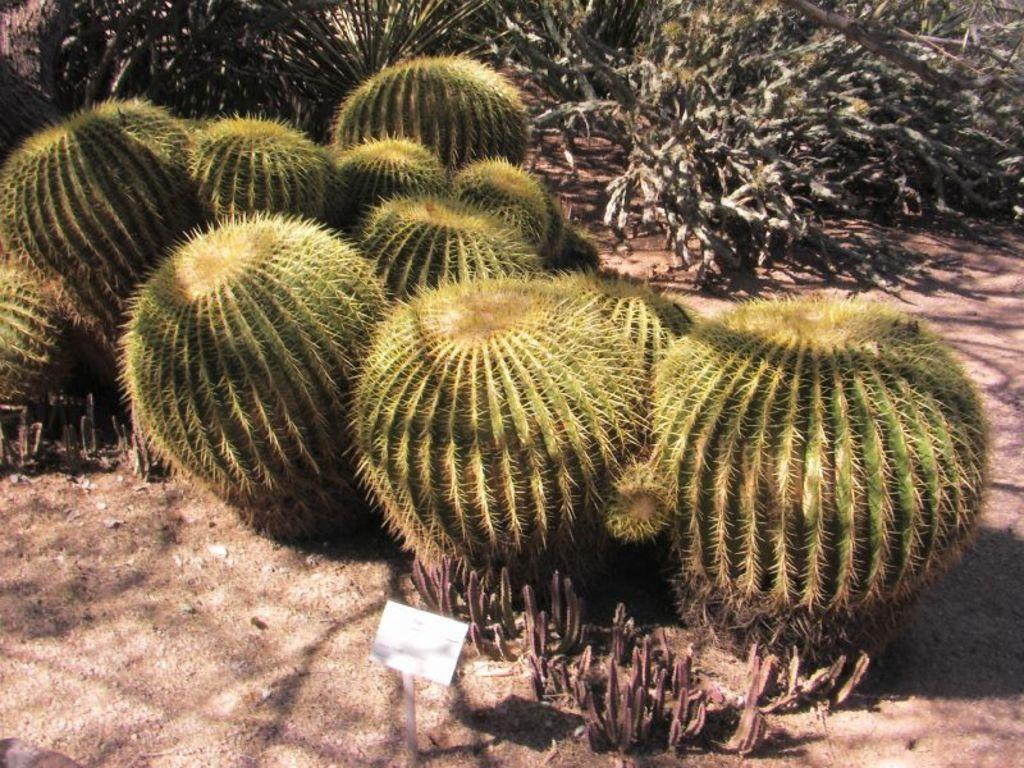What types of living organisms can be seen in the image? There are different types of plants in the image. Where are the plants located? The plants are on the ground in the image. Is there any signage or identification in the image? Yes, there is a name board in the image. How many oranges are hanging from the plants in the image? There are no oranges present in the image; it features different types of plants. What type of mailbox can be seen in the image? There is no mailbox present in the image. 